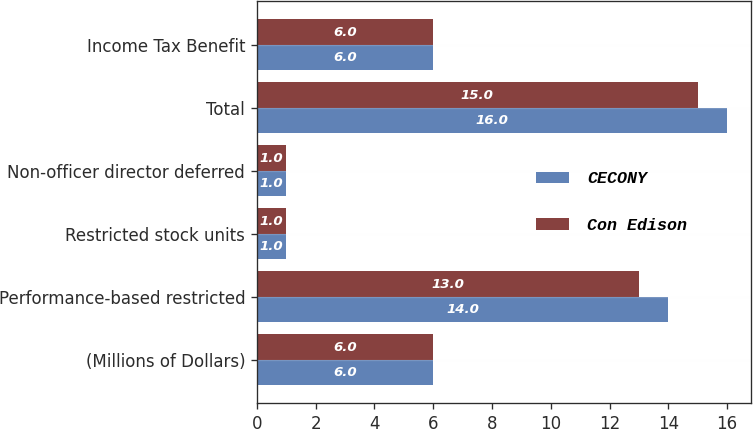Convert chart. <chart><loc_0><loc_0><loc_500><loc_500><stacked_bar_chart><ecel><fcel>(Millions of Dollars)<fcel>Performance-based restricted<fcel>Restricted stock units<fcel>Non-officer director deferred<fcel>Total<fcel>Income Tax Benefit<nl><fcel>CECONY<fcel>6<fcel>14<fcel>1<fcel>1<fcel>16<fcel>6<nl><fcel>Con Edison<fcel>6<fcel>13<fcel>1<fcel>1<fcel>15<fcel>6<nl></chart> 